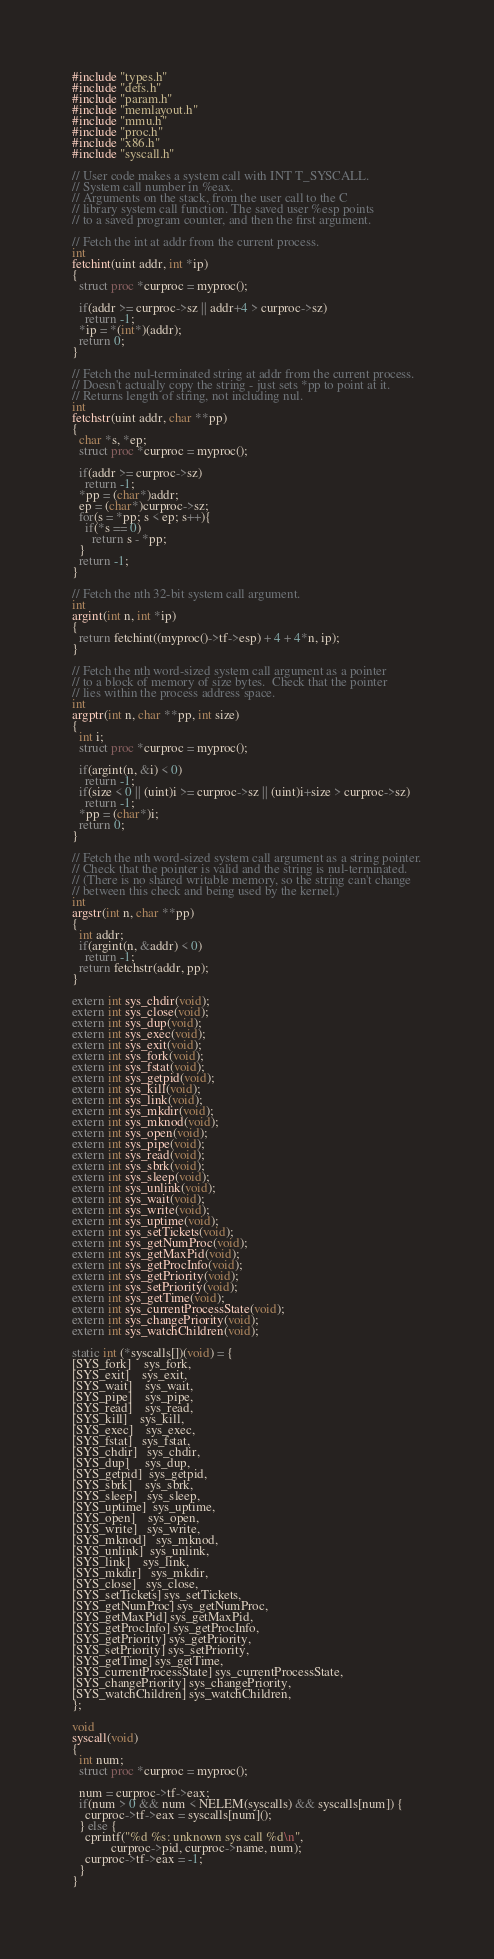Convert code to text. <code><loc_0><loc_0><loc_500><loc_500><_C_>#include "types.h"
#include "defs.h"
#include "param.h"
#include "memlayout.h"
#include "mmu.h"
#include "proc.h"
#include "x86.h"
#include "syscall.h"

// User code makes a system call with INT T_SYSCALL.
// System call number in %eax.
// Arguments on the stack, from the user call to the C
// library system call function. The saved user %esp points
// to a saved program counter, and then the first argument.

// Fetch the int at addr from the current process.
int
fetchint(uint addr, int *ip)
{
  struct proc *curproc = myproc();

  if(addr >= curproc->sz || addr+4 > curproc->sz)
    return -1;
  *ip = *(int*)(addr);
  return 0;
}

// Fetch the nul-terminated string at addr from the current process.
// Doesn't actually copy the string - just sets *pp to point at it.
// Returns length of string, not including nul.
int
fetchstr(uint addr, char **pp)
{
  char *s, *ep;
  struct proc *curproc = myproc();

  if(addr >= curproc->sz)
    return -1;
  *pp = (char*)addr;
  ep = (char*)curproc->sz;
  for(s = *pp; s < ep; s++){
    if(*s == 0)
      return s - *pp;
  }
  return -1;
}

// Fetch the nth 32-bit system call argument.
int
argint(int n, int *ip)
{
  return fetchint((myproc()->tf->esp) + 4 + 4*n, ip);
}

// Fetch the nth word-sized system call argument as a pointer
// to a block of memory of size bytes.  Check that the pointer
// lies within the process address space.
int
argptr(int n, char **pp, int size)
{
  int i;
  struct proc *curproc = myproc();

  if(argint(n, &i) < 0)
    return -1;
  if(size < 0 || (uint)i >= curproc->sz || (uint)i+size > curproc->sz)
    return -1;
  *pp = (char*)i;
  return 0;
}

// Fetch the nth word-sized system call argument as a string pointer.
// Check that the pointer is valid and the string is nul-terminated.
// (There is no shared writable memory, so the string can't change
// between this check and being used by the kernel.)
int
argstr(int n, char **pp)
{
  int addr;
  if(argint(n, &addr) < 0)
    return -1;
  return fetchstr(addr, pp);
}

extern int sys_chdir(void);
extern int sys_close(void);
extern int sys_dup(void);
extern int sys_exec(void);
extern int sys_exit(void);
extern int sys_fork(void);
extern int sys_fstat(void);
extern int sys_getpid(void);
extern int sys_kill(void);
extern int sys_link(void);
extern int sys_mkdir(void);
extern int sys_mknod(void);
extern int sys_open(void);
extern int sys_pipe(void);
extern int sys_read(void);
extern int sys_sbrk(void);
extern int sys_sleep(void);
extern int sys_unlink(void);
extern int sys_wait(void);
extern int sys_write(void);
extern int sys_uptime(void);
extern int sys_setTickets(void);
extern int sys_getNumProc(void);
extern int sys_getMaxPid(void);
extern int sys_getProcInfo(void);
extern int sys_getPriority(void);
extern int sys_setPriority(void);
extern int sys_getTime(void);
extern int sys_currentProcessState(void);
extern int sys_changePriority(void);
extern int sys_watchChildren(void);

static int (*syscalls[])(void) = {
[SYS_fork]    sys_fork,
[SYS_exit]    sys_exit,
[SYS_wait]    sys_wait,
[SYS_pipe]    sys_pipe,
[SYS_read]    sys_read,
[SYS_kill]    sys_kill,
[SYS_exec]    sys_exec,
[SYS_fstat]   sys_fstat,
[SYS_chdir]   sys_chdir,
[SYS_dup]     sys_dup,
[SYS_getpid]  sys_getpid,
[SYS_sbrk]    sys_sbrk,
[SYS_sleep]   sys_sleep,
[SYS_uptime]  sys_uptime,
[SYS_open]    sys_open,
[SYS_write]   sys_write,
[SYS_mknod]   sys_mknod,
[SYS_unlink]  sys_unlink,
[SYS_link]    sys_link,
[SYS_mkdir]   sys_mkdir,
[SYS_close]   sys_close,
[SYS_setTickets] sys_setTickets,
[SYS_getNumProc] sys_getNumProc,
[SYS_getMaxPid] sys_getMaxPid,
[SYS_getProcInfo] sys_getProcInfo,
[SYS_getPriority] sys_getPriority,
[SYS_setPriority] sys_setPriority,
[SYS_getTime] sys_getTime,
[SYS_currentProcessState] sys_currentProcessState,
[SYS_changePriority] sys_changePriority,
[SYS_watchChildren] sys_watchChildren,
};

void
syscall(void)
{
  int num;
  struct proc *curproc = myproc();

  num = curproc->tf->eax;
  if(num > 0 && num < NELEM(syscalls) && syscalls[num]) {
    curproc->tf->eax = syscalls[num]();
  } else {
    cprintf("%d %s: unknown sys call %d\n",
            curproc->pid, curproc->name, num);
    curproc->tf->eax = -1;
  }
}
</code> 